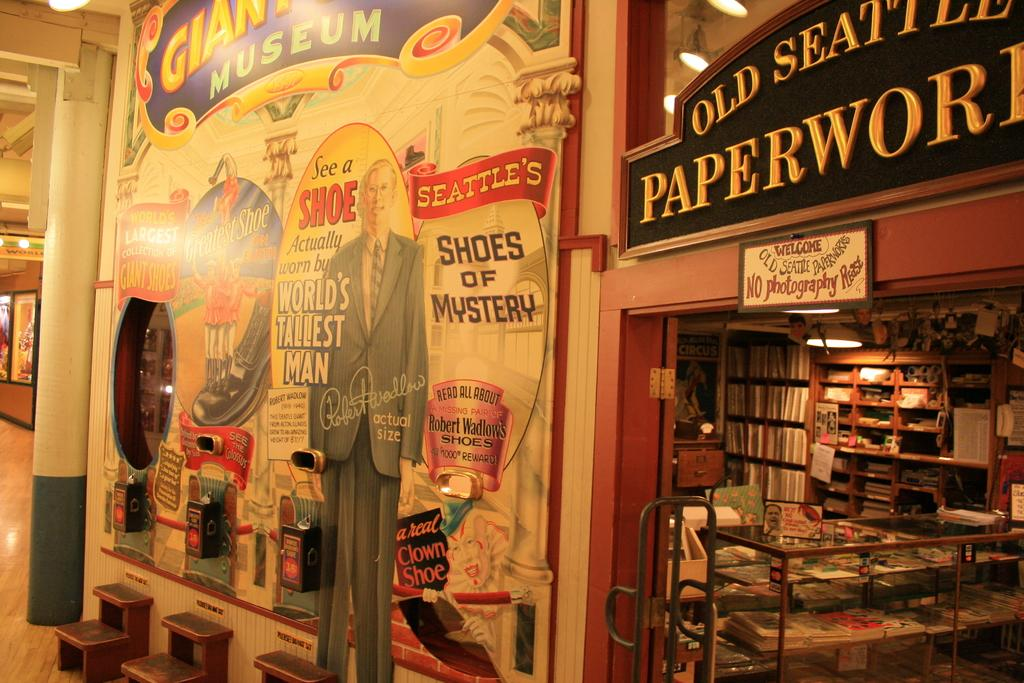<image>
Present a compact description of the photo's key features. A store front with lots of books called Old Seattle Paperwork. 